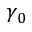Convert formula to latex. <formula><loc_0><loc_0><loc_500><loc_500>\gamma _ { 0 }</formula> 